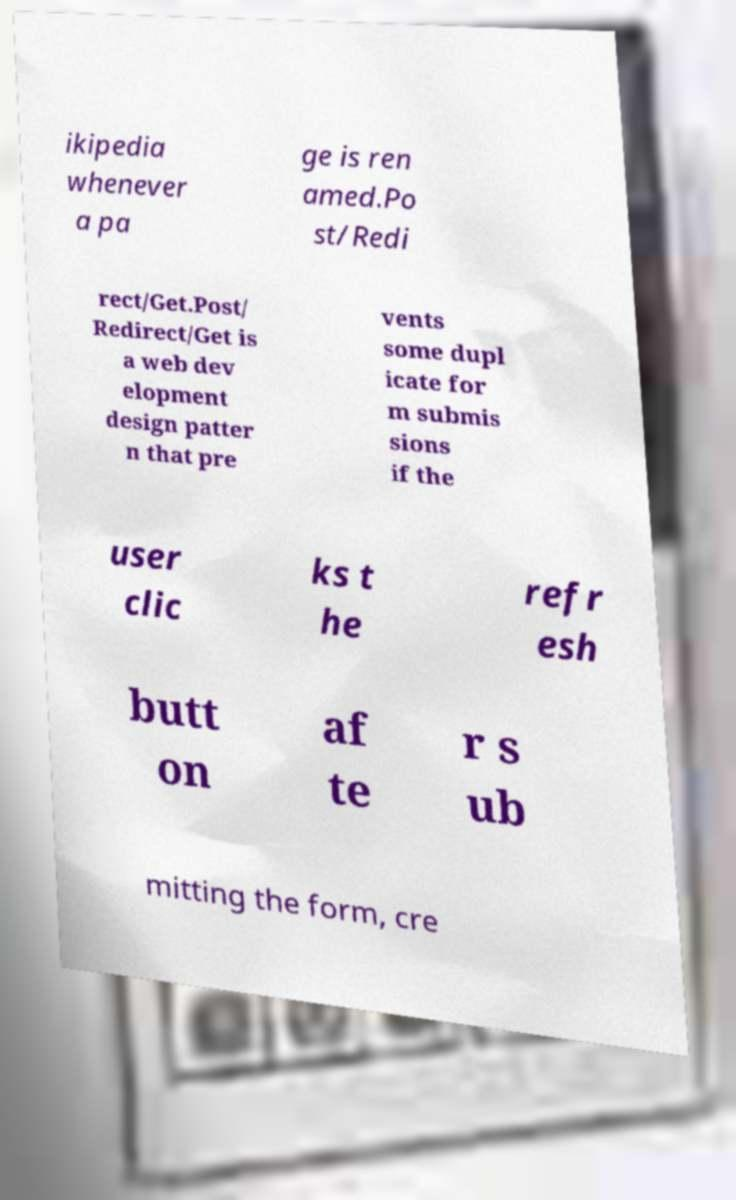For documentation purposes, I need the text within this image transcribed. Could you provide that? ikipedia whenever a pa ge is ren amed.Po st/Redi rect/Get.Post/ Redirect/Get is a web dev elopment design patter n that pre vents some dupl icate for m submis sions if the user clic ks t he refr esh butt on af te r s ub mitting the form, cre 